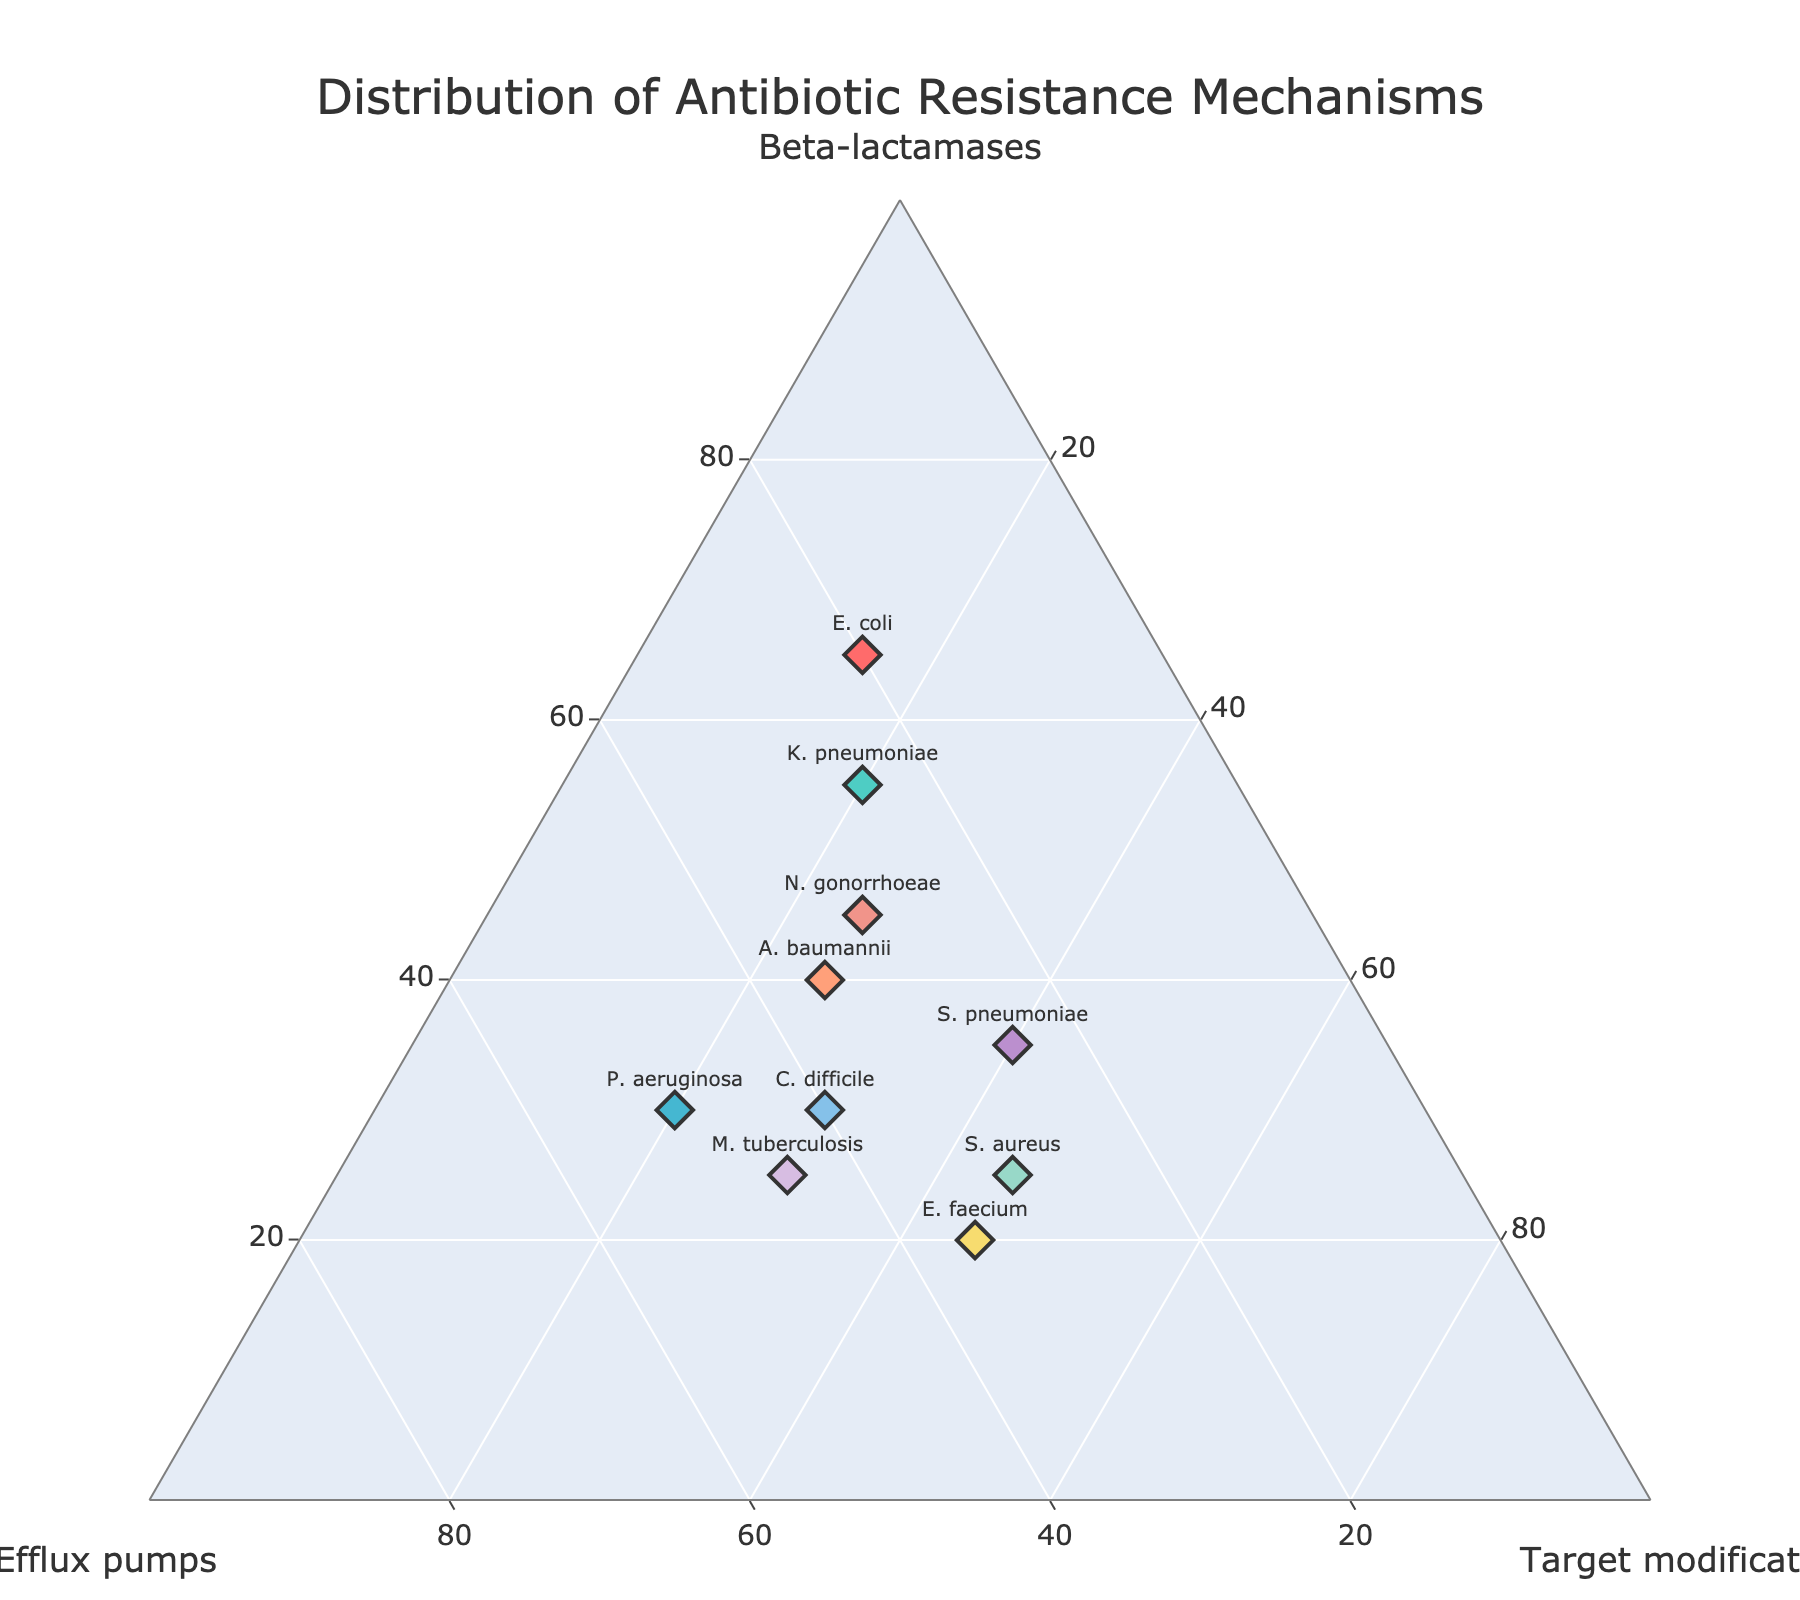What's the title of the figure? The title is usually displayed at the top-center of the figure. Based on the figure, the title reads "Distribution of Antibiotic Resistance Mechanisms".
Answer: Distribution of Antibiotic Resistance Mechanisms How many bacterial isolates are represented in the plot? Each bacterium is represented by a diamond-shaped marker on the plot. The number of markers corresponds to the number of bacterial isolates. Counting them, there are 10 markers.
Answer: 10 Which bacterium has the highest proportion of Beta-lactamases? The vertices of the ternary plot representing Beta-lactamases have the highest a-axis values. E. coli has the highest value at 65%.
Answer: E. coli Which bacterium has an equal distribution of all three resistance mechanisms? All vertices should have similar or equal values for a bacterium to have an equal distribution. C. difficile is closest with values 30%, 40%, and 30%.
Answer: C. difficile Which bacterium is closest to having the equal proportions of Efflux pumps and Target modifications? Look for bacterial points where the b-axis (Efflux pumps) and c-axis (Target modifications) values are close. S. aureus and E. faecium both have 30% Efflux pumps and 45% Target modifications.
Answer: S. aureus and E. faecium What is the color of the marker representing N. gonorrhoeae? Each bacterium is represented by a marker with a specific color. N. gonorrhoeae is represented by a marker with a pinkish color.
Answer: Pinkish Between A. baumannii and P. aeruginosa, which one has a higher value of Efflux pumps? Compare the b-axis values for both bacteria. P. aeruginosa has 50% and A. baumannii has 35%.
Answer: P. aeruginosa If we average the proportion of Target modifications for S. pneumoniae and M. tuberculosis, what do we get? Add the values of Target modifications for S. pneumoniae (40%) and M. tuberculosis (30%), then divide by 2. (40 + 30) / 2 = 35%.
Answer: 35% Which bacterium has the closest proportions between Beta-lactamases and Efflux pumps? Look for bacterial points where the a-axis (Beta-lactamases) and b-axis (Efflux pumps) values are close. K. pneumoniae is closest with 55% Beta-lactamases and 25% Efflux pumps.
Answer: K. pneumoniae 